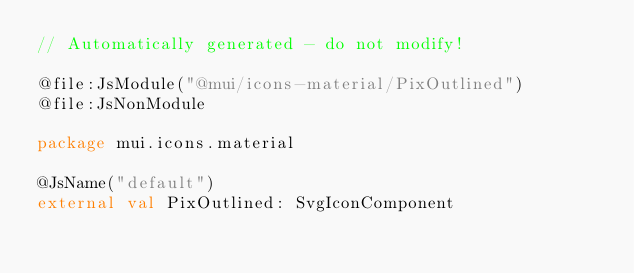Convert code to text. <code><loc_0><loc_0><loc_500><loc_500><_Kotlin_>// Automatically generated - do not modify!

@file:JsModule("@mui/icons-material/PixOutlined")
@file:JsNonModule

package mui.icons.material

@JsName("default")
external val PixOutlined: SvgIconComponent
</code> 